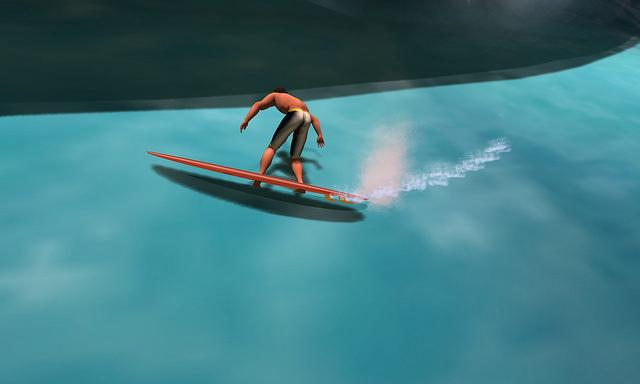How was this artwork created? Please explain your reasoning. digitally. This was done on a computer by a graphic artist. 